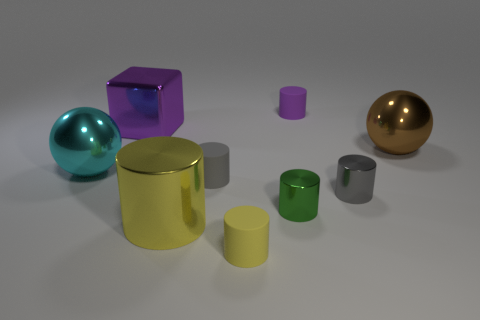Subtract 2 cylinders. How many cylinders are left? 4 Subtract all purple cylinders. How many cylinders are left? 5 Subtract all purple rubber cylinders. How many cylinders are left? 5 Subtract all cyan cylinders. Subtract all blue spheres. How many cylinders are left? 6 Add 1 large brown balls. How many objects exist? 10 Subtract all cubes. How many objects are left? 8 Subtract all cyan metallic objects. Subtract all tiny yellow rubber objects. How many objects are left? 7 Add 6 shiny balls. How many shiny balls are left? 8 Add 1 brown rubber balls. How many brown rubber balls exist? 1 Subtract 0 cyan blocks. How many objects are left? 9 